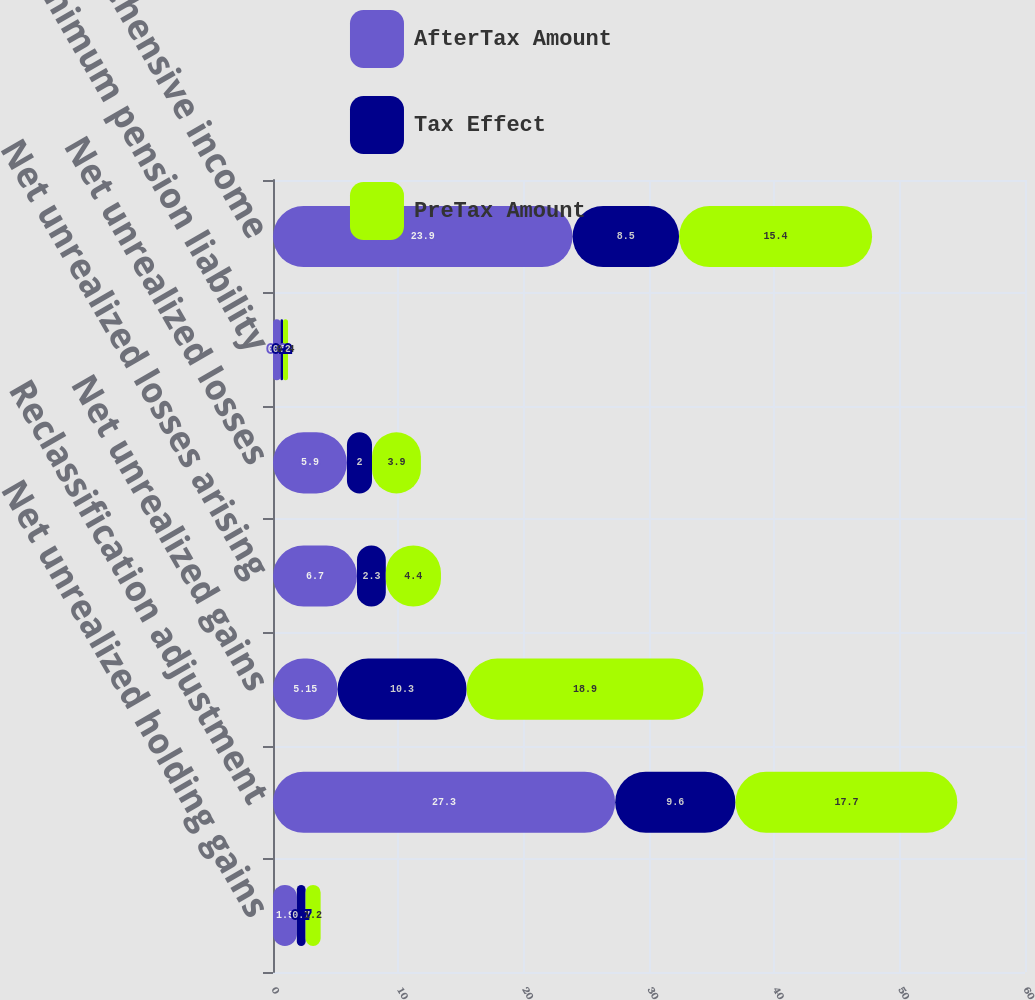Convert chart. <chart><loc_0><loc_0><loc_500><loc_500><stacked_bar_chart><ecel><fcel>Net unrealized holding gains<fcel>Reclassification adjustment<fcel>Net unrealized gains<fcel>Net unrealized losses arising<fcel>Net unrealized losses<fcel>Minimum pension liability<fcel>Other comprehensive income<nl><fcel>AfterTax Amount<fcel>1.9<fcel>27.3<fcel>5.15<fcel>6.7<fcel>5.9<fcel>0.6<fcel>23.9<nl><fcel>Tax Effect<fcel>0.7<fcel>9.6<fcel>10.3<fcel>2.3<fcel>2<fcel>0.2<fcel>8.5<nl><fcel>PreTax Amount<fcel>1.2<fcel>17.7<fcel>18.9<fcel>4.4<fcel>3.9<fcel>0.4<fcel>15.4<nl></chart> 